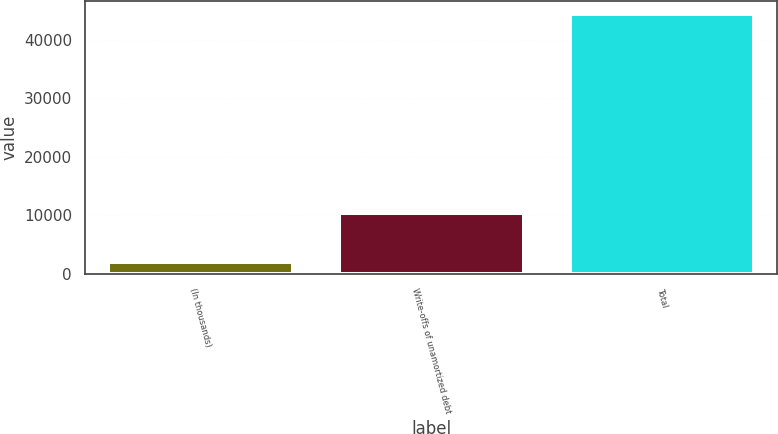Convert chart. <chart><loc_0><loc_0><loc_500><loc_500><bar_chart><fcel>(In thousands)<fcel>Write-offs of unamortized debt<fcel>Total<nl><fcel>2014<fcel>10451<fcel>44422<nl></chart> 